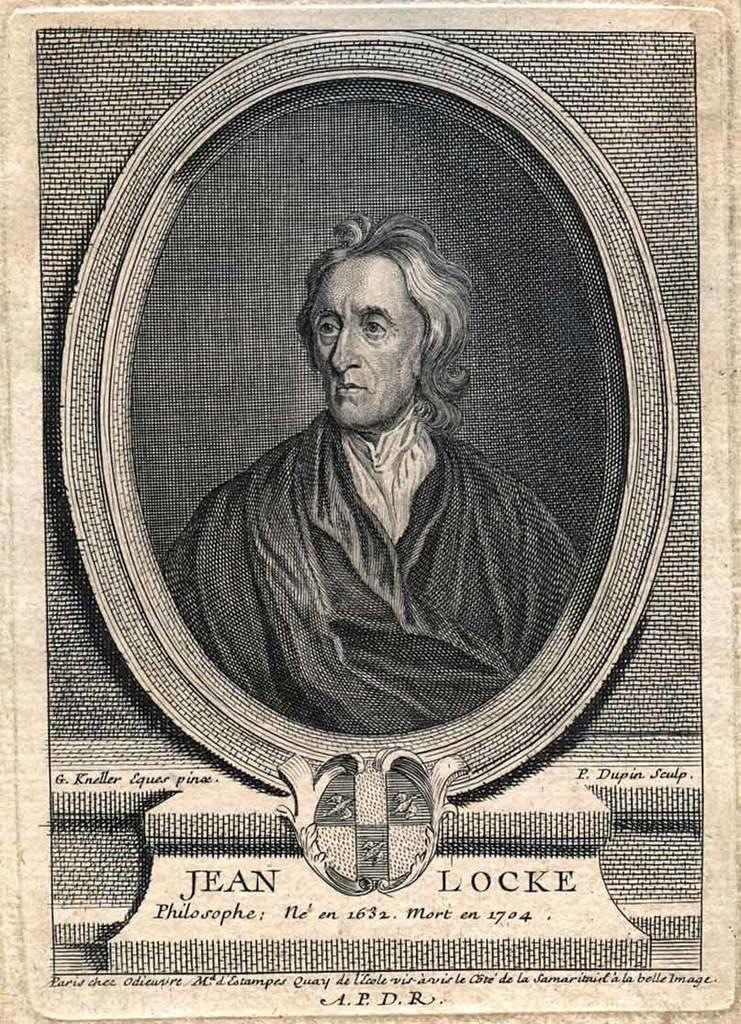Provide a one-sentence caption for the provided image. A close up black and white portrait of Jean Locke. 